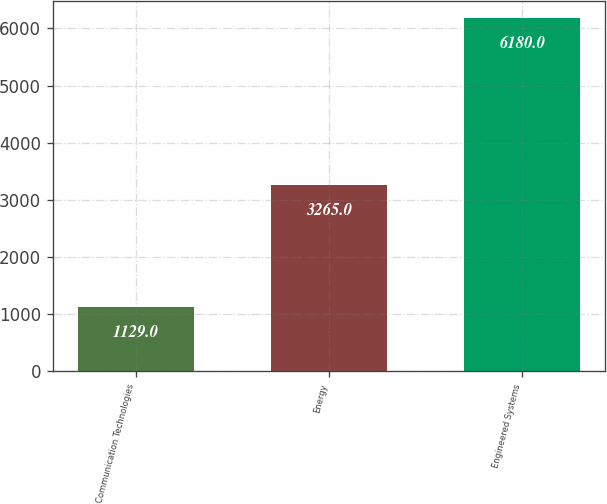<chart> <loc_0><loc_0><loc_500><loc_500><bar_chart><fcel>Communication Technologies<fcel>Energy<fcel>Engineered Systems<nl><fcel>1129<fcel>3265<fcel>6180<nl></chart> 